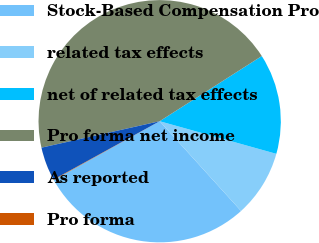Convert chart. <chart><loc_0><loc_0><loc_500><loc_500><pie_chart><fcel>Stock-Based Compensation Pro<fcel>related tax effects<fcel>net of related tax effects<fcel>Pro forma net income<fcel>As reported<fcel>Pro forma<nl><fcel>28.66%<fcel>8.94%<fcel>13.38%<fcel>44.47%<fcel>4.5%<fcel>0.06%<nl></chart> 